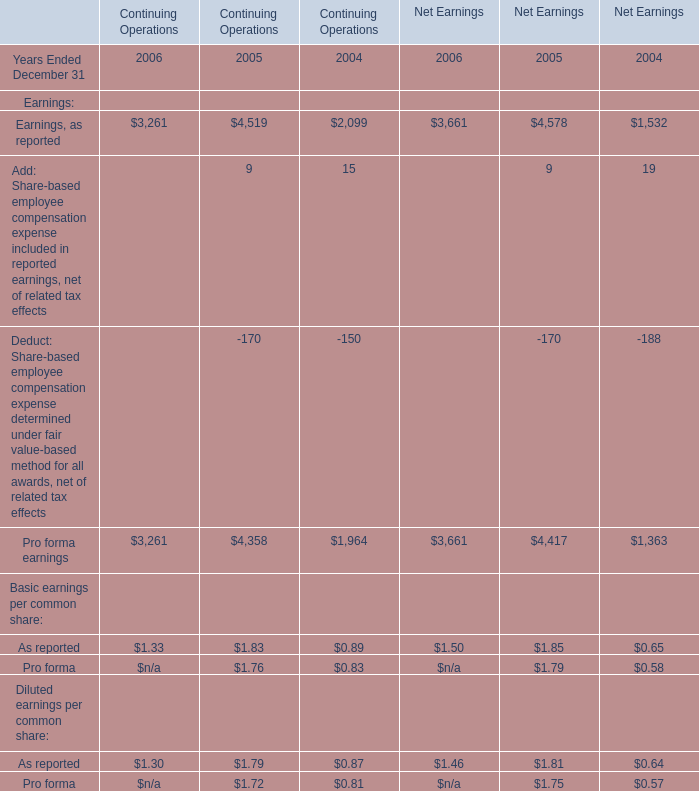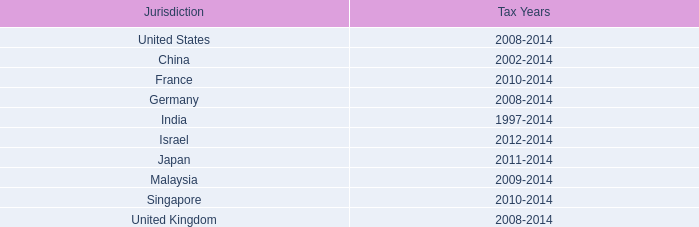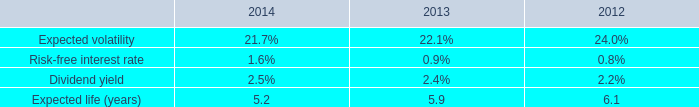Which year Ended December 31 is Pro forma earnings for Continuing Operations the most? 
Answer: 2005. 